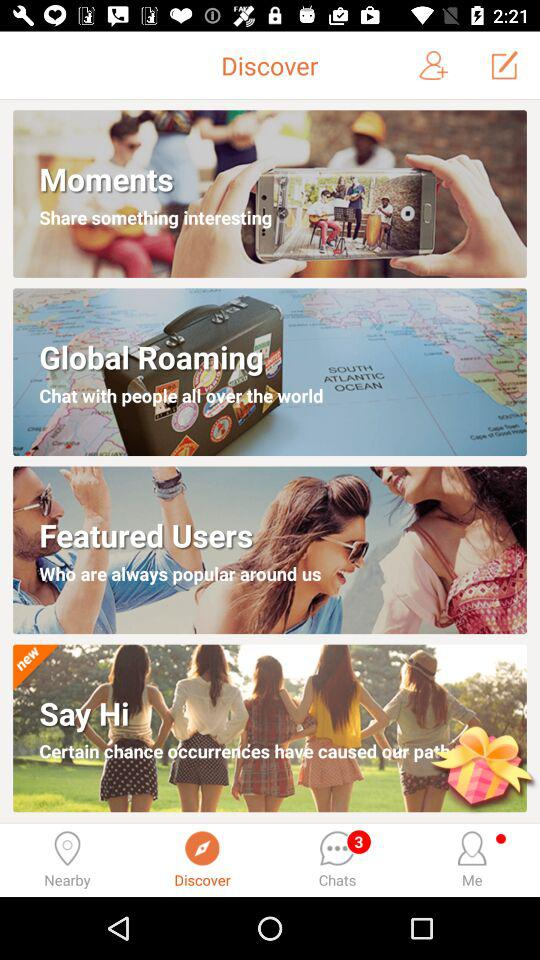Which option has been selected? The option that has been selected is "Discover". 